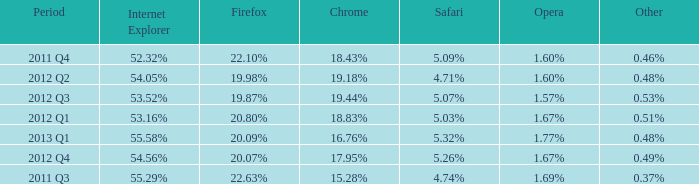What period has 53.52% as the internet explorer? 2012 Q3. 